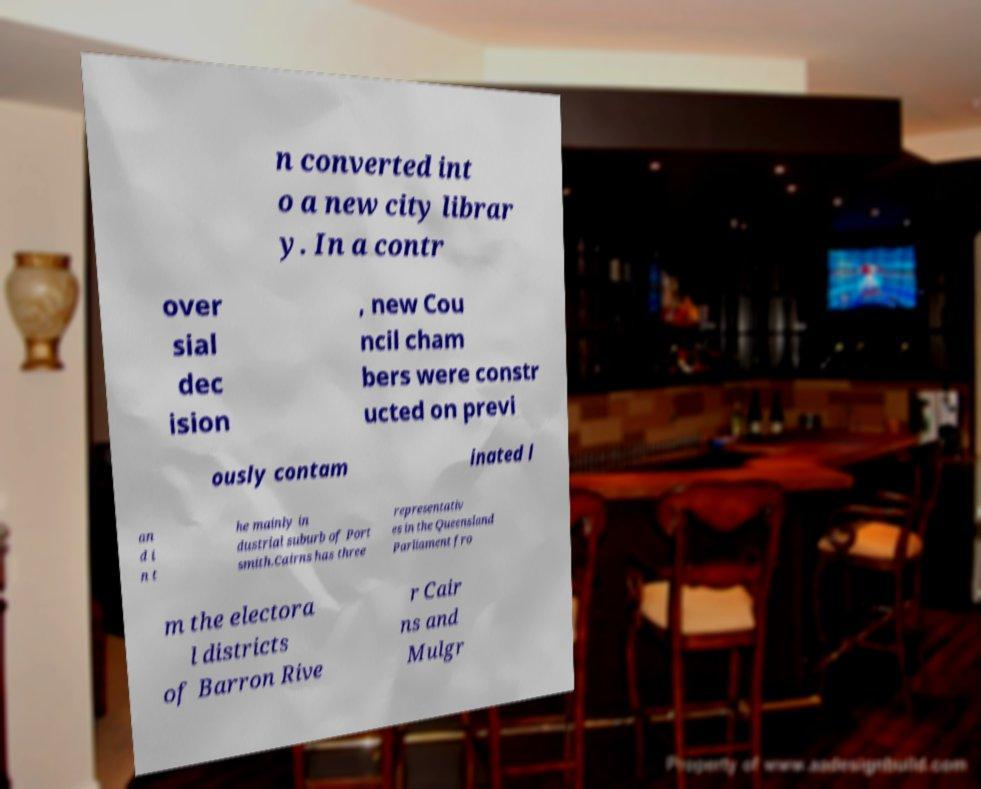Can you accurately transcribe the text from the provided image for me? n converted int o a new city librar y. In a contr over sial dec ision , new Cou ncil cham bers were constr ucted on previ ously contam inated l an d i n t he mainly in dustrial suburb of Port smith.Cairns has three representativ es in the Queensland Parliament fro m the electora l districts of Barron Rive r Cair ns and Mulgr 